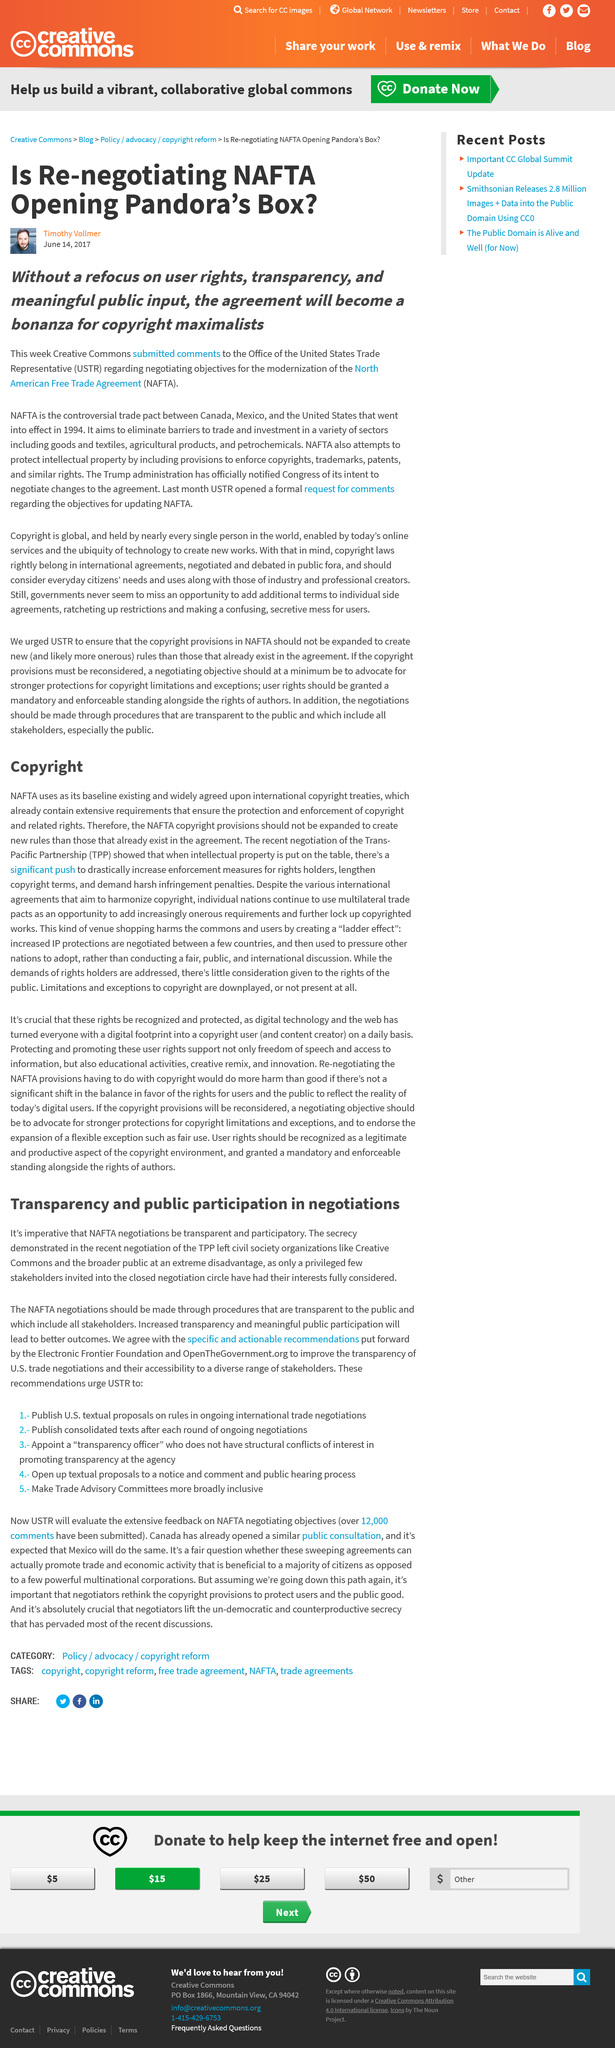Identify some key points in this picture. Increased transparency and meaningful public participation will result in better outcomes. Negotiations for the North American Free Trade Agreement (NAFTA) must be transparent and participatory in order to ensure that the interests of all stakeholders are taken into account and that the agreement serves the collective good. The agreement will ultimately benefit those who advocate for excessive and restrictive copyright laws, also known as copyright maximalists, to the detriment of creators and the public's right to access and use copyrighted works. The CC submitted its comments to the USTR in June 2017. The recent negotiation of the TPP left organizations at a disadvantage due to secrecy. 